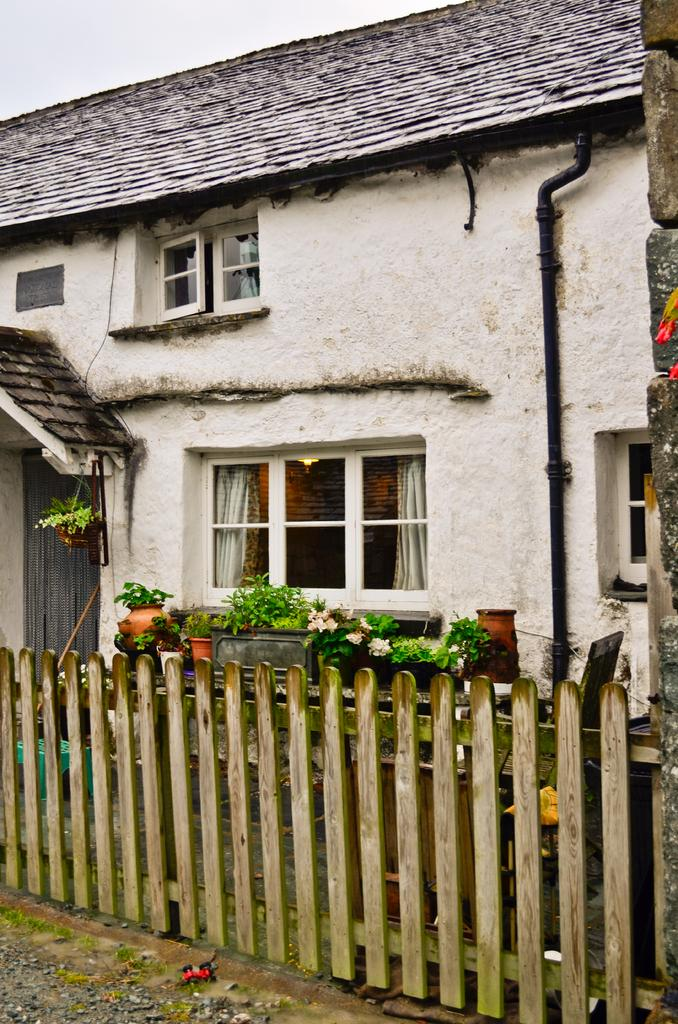What type of structure is present in the image? There is a house in the image. What features can be observed on the house? The house has windows, and the windows have curtains. What other objects are visible in the image? There is a pipe, fencing, and flower pots in the image. What is the color of the sky in the image? The sky is white in color. Where is the school located in the image? There is no school present in the image; it features a house with windows, curtains, a pipe, fencing, flower pots, and a white sky. Can you see a bed in the image? There is no bed present in the image. 